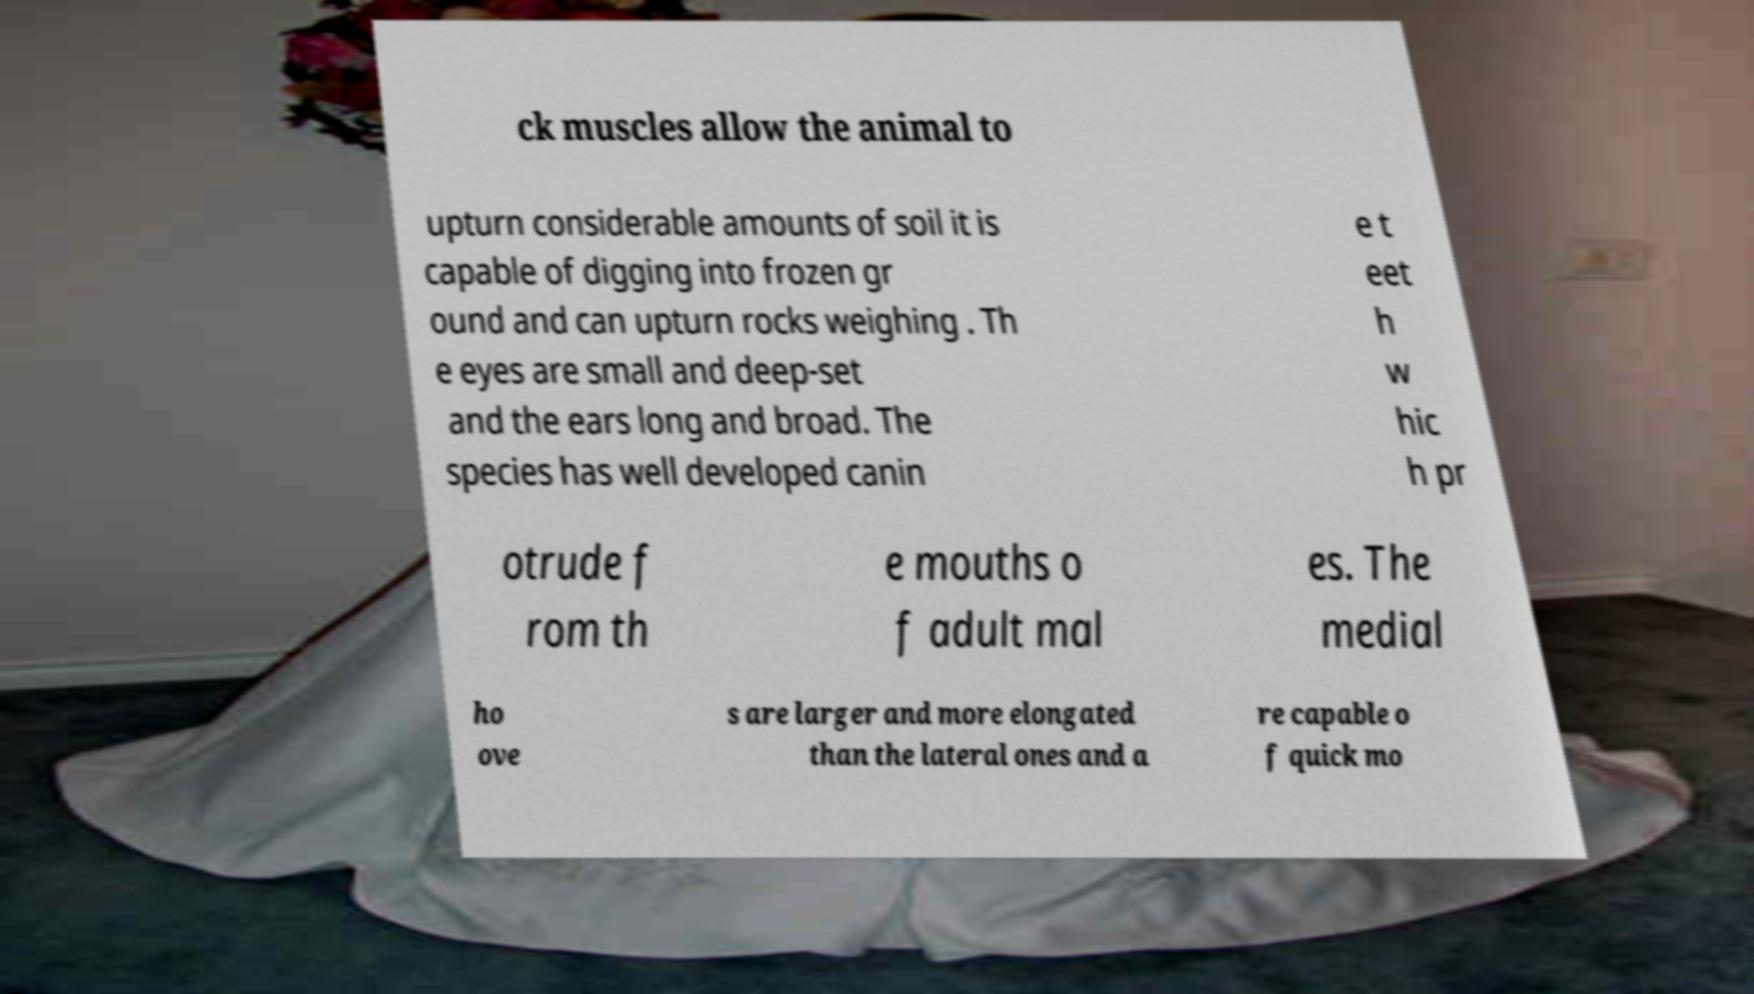Could you extract and type out the text from this image? ck muscles allow the animal to upturn considerable amounts of soil it is capable of digging into frozen gr ound and can upturn rocks weighing . Th e eyes are small and deep-set and the ears long and broad. The species has well developed canin e t eet h w hic h pr otrude f rom th e mouths o f adult mal es. The medial ho ove s are larger and more elongated than the lateral ones and a re capable o f quick mo 